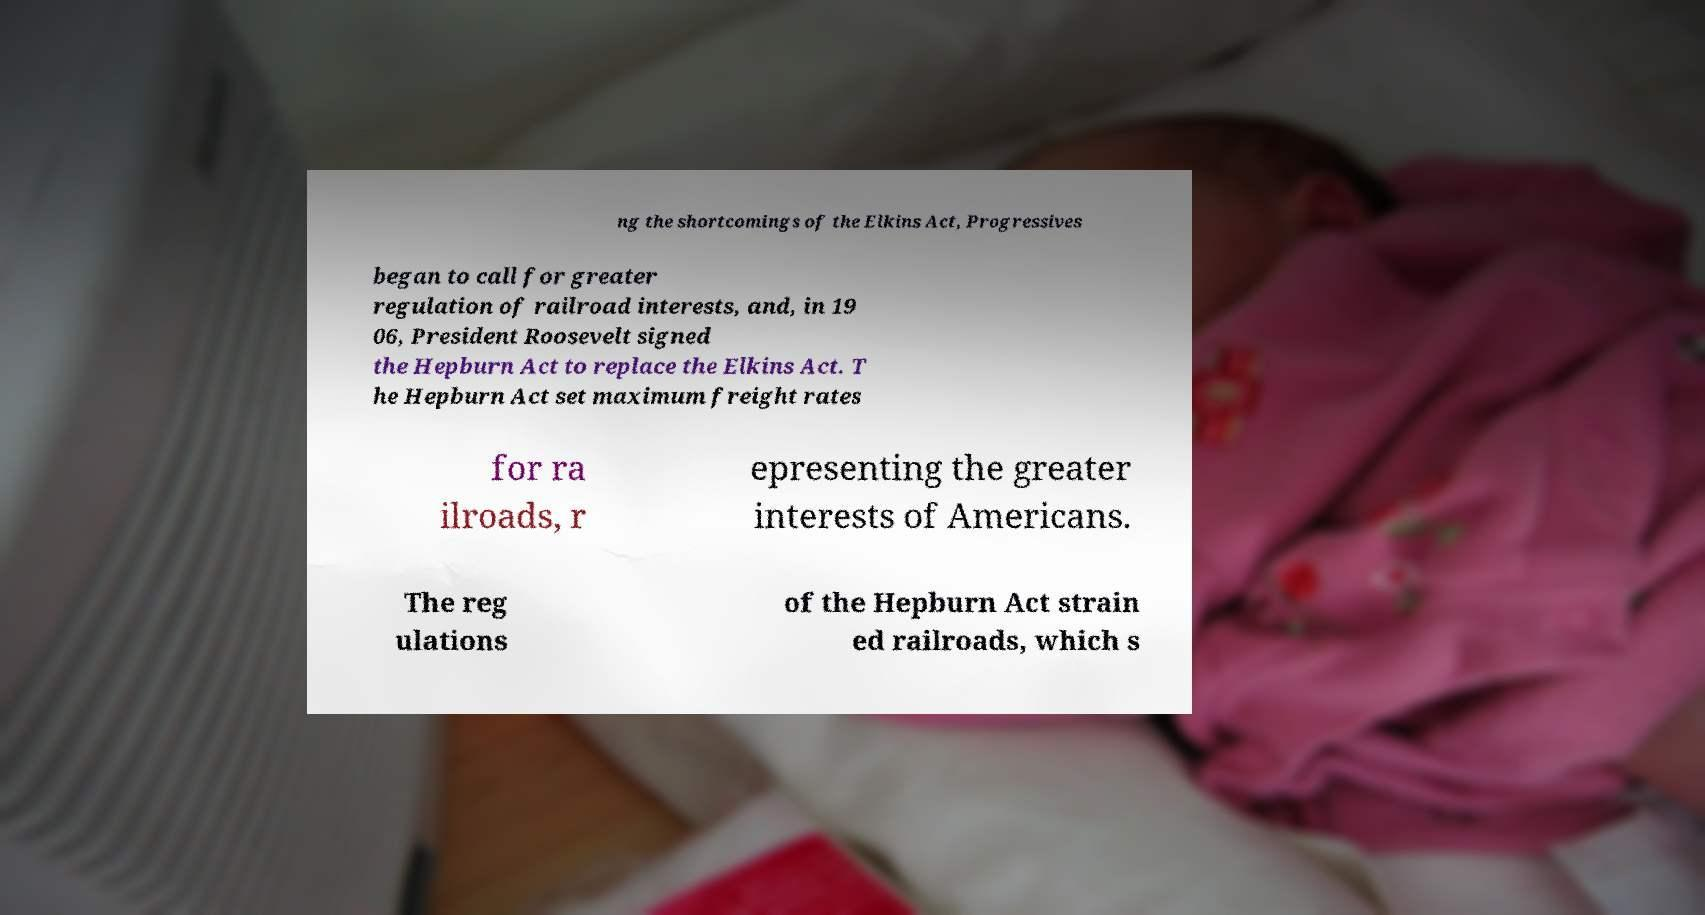Please read and relay the text visible in this image. What does it say? ng the shortcomings of the Elkins Act, Progressives began to call for greater regulation of railroad interests, and, in 19 06, President Roosevelt signed the Hepburn Act to replace the Elkins Act. T he Hepburn Act set maximum freight rates for ra ilroads, r epresenting the greater interests of Americans. The reg ulations of the Hepburn Act strain ed railroads, which s 